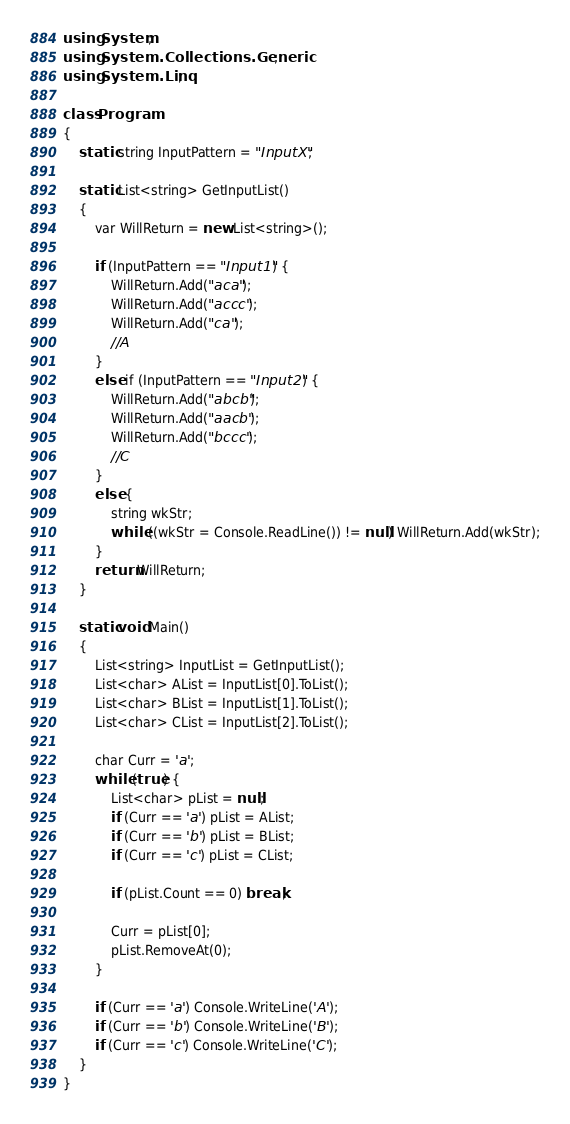Convert code to text. <code><loc_0><loc_0><loc_500><loc_500><_C#_>using System;
using System.Collections.Generic;
using System.Linq;

class Program
{
    static string InputPattern = "InputX";

    static List<string> GetInputList()
    {
        var WillReturn = new List<string>();

        if (InputPattern == "Input1") {
            WillReturn.Add("aca");
            WillReturn.Add("accc");
            WillReturn.Add("ca");
            //A
        }
        else if (InputPattern == "Input2") {
            WillReturn.Add("abcb");
            WillReturn.Add("aacb");
            WillReturn.Add("bccc");
            //C
        }
        else {
            string wkStr;
            while ((wkStr = Console.ReadLine()) != null) WillReturn.Add(wkStr);
        }
        return WillReturn;
    }

    static void Main()
    {
        List<string> InputList = GetInputList();
        List<char> AList = InputList[0].ToList();
        List<char> BList = InputList[1].ToList();
        List<char> CList = InputList[2].ToList();

        char Curr = 'a';
        while (true) {
            List<char> pList = null;
            if (Curr == 'a') pList = AList;
            if (Curr == 'b') pList = BList;
            if (Curr == 'c') pList = CList;

            if (pList.Count == 0) break;

            Curr = pList[0];
            pList.RemoveAt(0);
        }

        if (Curr == 'a') Console.WriteLine('A');
        if (Curr == 'b') Console.WriteLine('B');
        if (Curr == 'c') Console.WriteLine('C');
    }
}
</code> 